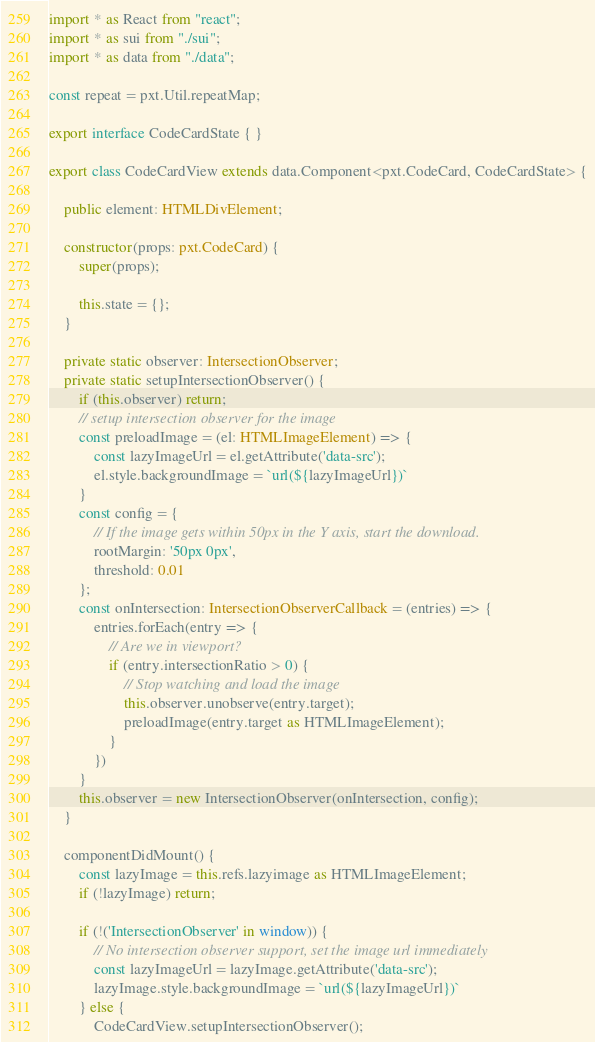<code> <loc_0><loc_0><loc_500><loc_500><_TypeScript_>import * as React from "react";
import * as sui from "./sui";
import * as data from "./data";

const repeat = pxt.Util.repeatMap;

export interface CodeCardState { }

export class CodeCardView extends data.Component<pxt.CodeCard, CodeCardState> {

    public element: HTMLDivElement;

    constructor(props: pxt.CodeCard) {
        super(props);

        this.state = {};
    }

    private static observer: IntersectionObserver;
    private static setupIntersectionObserver() {
        if (this.observer) return;
        // setup intersection observer for the image
        const preloadImage = (el: HTMLImageElement) => {
            const lazyImageUrl = el.getAttribute('data-src');
            el.style.backgroundImage = `url(${lazyImageUrl})`
        }
        const config = {
            // If the image gets within 50px in the Y axis, start the download.
            rootMargin: '50px 0px',
            threshold: 0.01
        };
        const onIntersection: IntersectionObserverCallback = (entries) => {
            entries.forEach(entry => {
                // Are we in viewport?
                if (entry.intersectionRatio > 0) {
                    // Stop watching and load the image
                    this.observer.unobserve(entry.target);
                    preloadImage(entry.target as HTMLImageElement);
                }
            })
        }
        this.observer = new IntersectionObserver(onIntersection, config);
    }

    componentDidMount() {
        const lazyImage = this.refs.lazyimage as HTMLImageElement;
        if (!lazyImage) return;

        if (!('IntersectionObserver' in window)) {
            // No intersection observer support, set the image url immediately
            const lazyImageUrl = lazyImage.getAttribute('data-src');
            lazyImage.style.backgroundImage = `url(${lazyImageUrl})`
        } else {
            CodeCardView.setupIntersectionObserver();</code> 